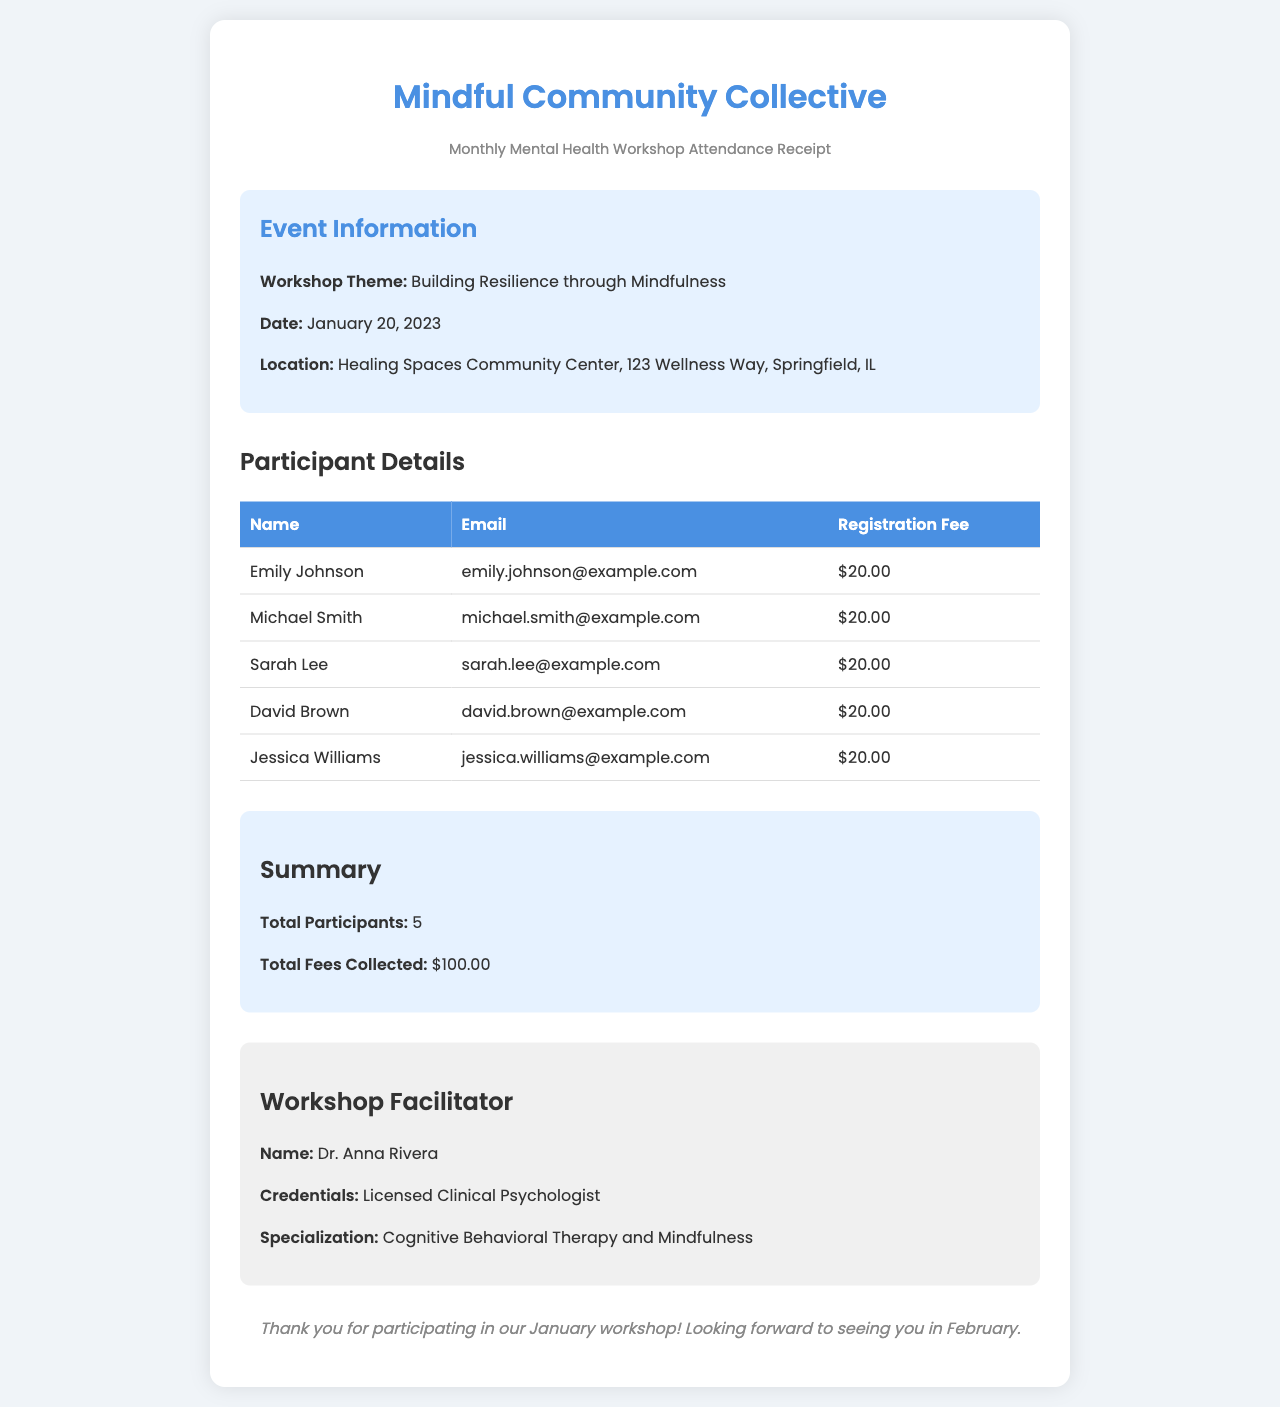What was the workshop theme? The workshop theme is stated clearly in the document as "Building Resilience through Mindfulness."
Answer: Building Resilience through Mindfulness When was the workshop held? The date of the workshop is mentioned in the event details as January 20, 2023.
Answer: January 20, 2023 How many participants attended the workshop? The total number of participants is summarized in the document as 5 under the summary section.
Answer: 5 What is the total fees collected from participants? The total fees collected is provided in the summary section as $100.00.
Answer: $100.00 Who was the workshop facilitator? The name of the facilitator is listed in the facilitator section as Dr. Anna Rivera.
Answer: Dr. Anna Rivera What type of therapy does the facilitator specialize in? The specialization of the facilitator is indicated as Cognitive Behavioral Therapy and Mindfulness in the document.
Answer: Cognitive Behavioral Therapy and Mindfulness What is the email of the first participant? The document lists the email of the first participant, Emily Johnson, as emily.johnson@example.com.
Answer: emily.johnson@example.com What location hosted the workshop? The location of the workshop is specified as Healing Spaces Community Center, 123 Wellness Way, Springfield, IL.
Answer: Healing Spaces Community Center, 123 Wellness Way, Springfield, IL What credentials does the workshop facilitator hold? The credentials of the facilitator are listed as Licensed Clinical Psychologist.
Answer: Licensed Clinical Psychologist 